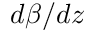<formula> <loc_0><loc_0><loc_500><loc_500>d \beta / d z</formula> 